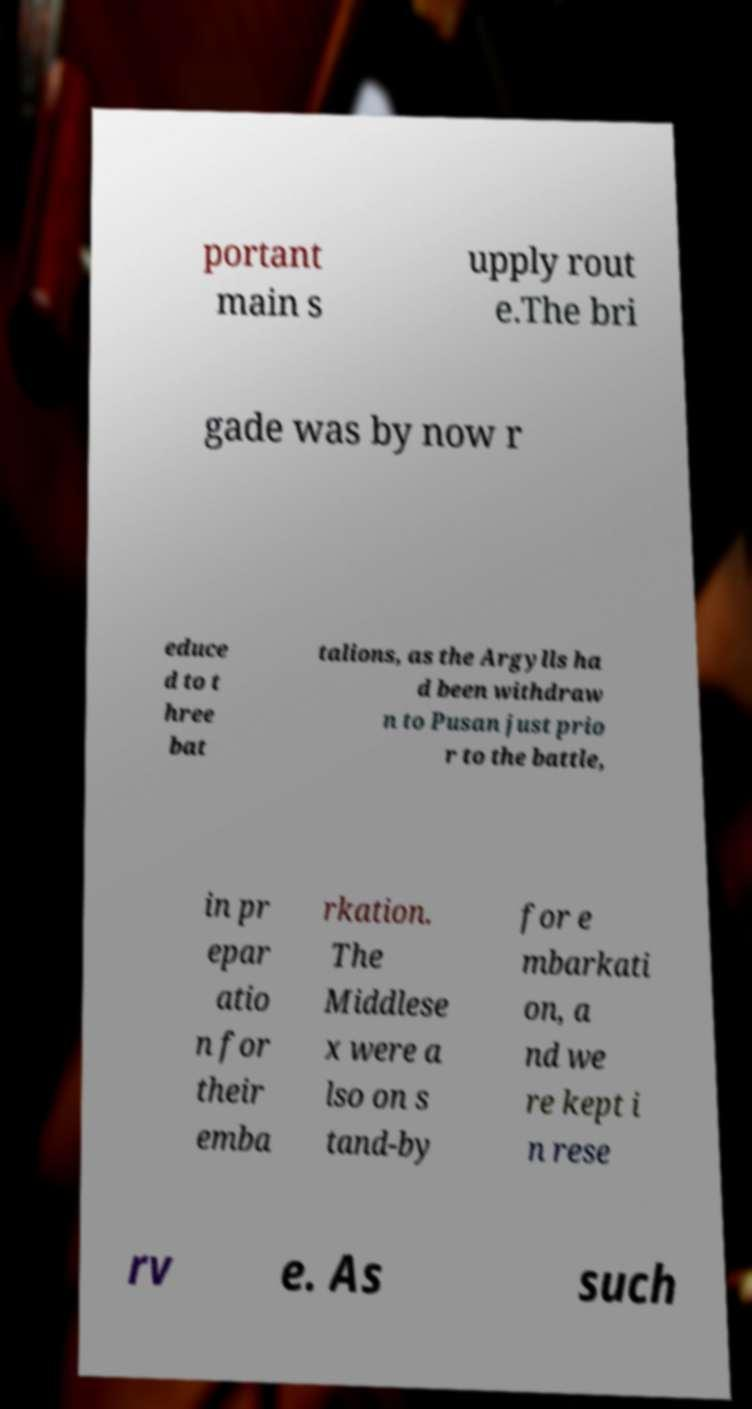I need the written content from this picture converted into text. Can you do that? portant main s upply rout e.The bri gade was by now r educe d to t hree bat talions, as the Argylls ha d been withdraw n to Pusan just prio r to the battle, in pr epar atio n for their emba rkation. The Middlese x were a lso on s tand-by for e mbarkati on, a nd we re kept i n rese rv e. As such 